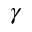Convert formula to latex. <formula><loc_0><loc_0><loc_500><loc_500>\gamma</formula> 